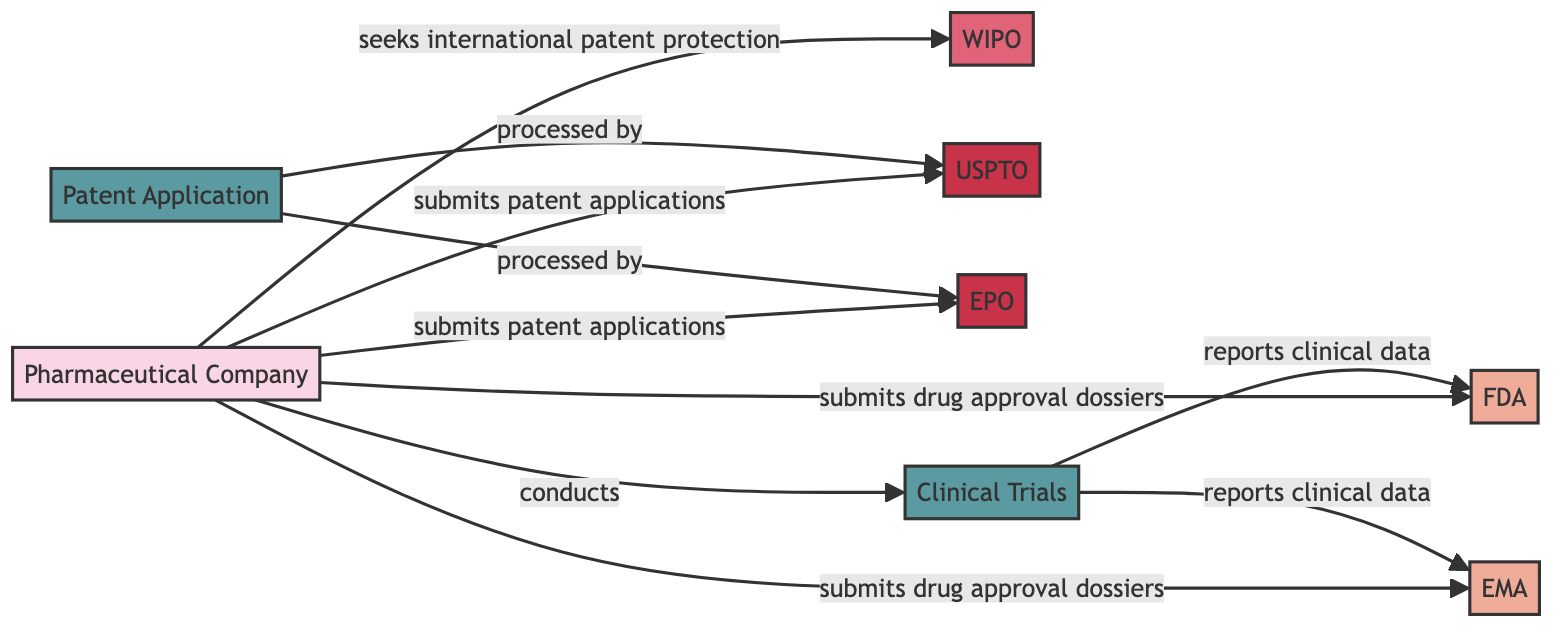What is the total number of nodes in the diagram? There are 8 nodes represented in the diagram, including entities, regulatory bodies, patent offices, and processes.
Answer: 8 What relationship does the Pharmaceutical Company have with the FDA? The Pharmaceutical Company submits drug approval dossiers to the FDA, indicating their interaction in the drug approval process.
Answer: submits drug approval dossiers to Which regulatory body receives clinical data reports from Clinical Trials? Both the FDA and EMA receive clinical data reports from Clinical Trials, showing their role in evaluating clinical trial outcomes.
Answer: FDA and EMA How many patent offices are listed in the diagram? There are 2 patent offices mentioned in the diagram, which are the USPTO and EPO, both responsible for processing patent applications.
Answer: 2 What is the primary process conducted by the Pharmaceutical Company? The primary process is Clinical Trials, which is essential for generating data needed for drug approval and regulatory review.
Answer: Clinical Trials Which entity seeks international patent protection from WIPO? The Pharmaceutical Company seeks international patent protection from WIPO, emphasizing its desire to protect intellectual properties across multiple jurisdictions.
Answer: Pharmaceutical Company What do both the USPTO and EPO do with the Patent Application? Both the USPTO and EPO process the Patent Application, indicating their role in granting patents for new inventions in their respective regions.
Answer: processed by What is the flow of information from Clinical Trials to regulatory bodies? Clinical Trials report clinical data to both the FDA and EMA, illustrating the pathway through which trial results inform regulatory decisions.
Answer: reports clinical data to 